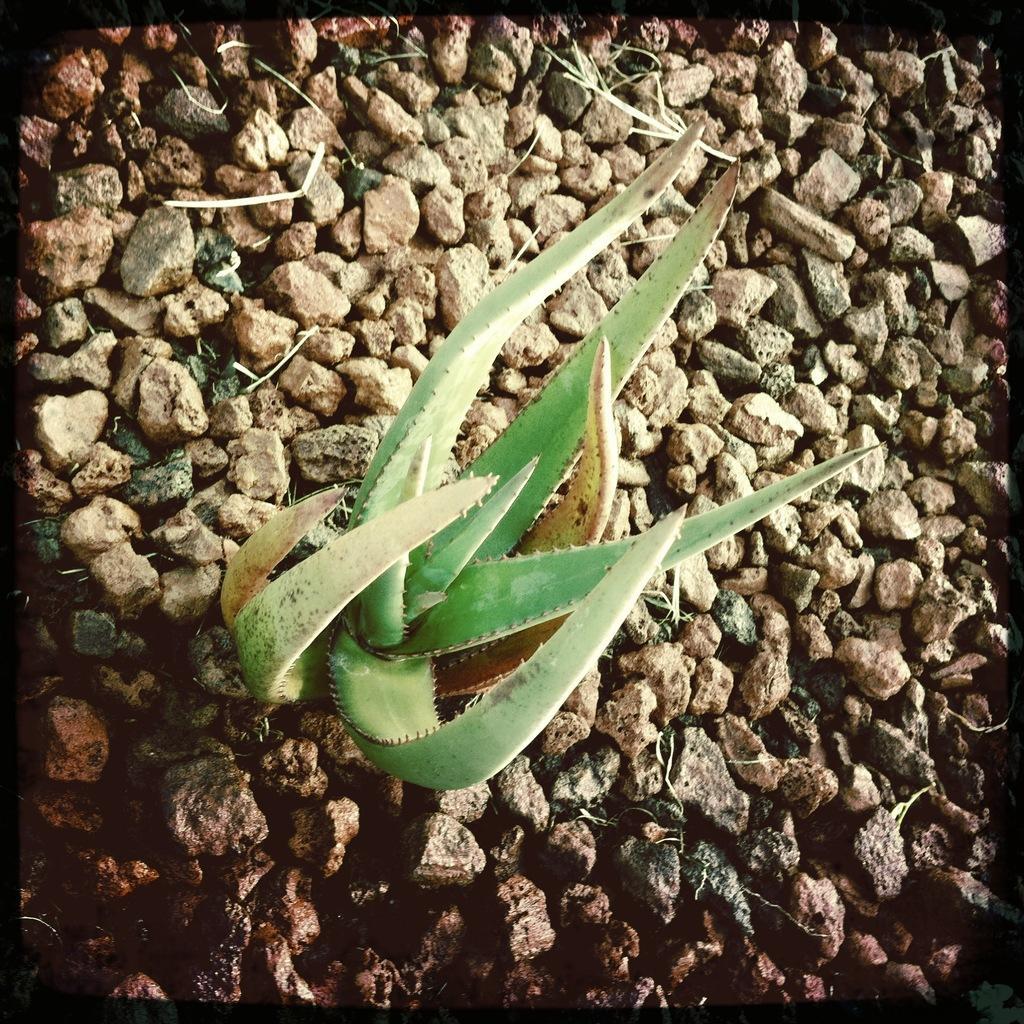Describe this image in one or two sentences. In the image there is an aloe vera plant in between the stones. 